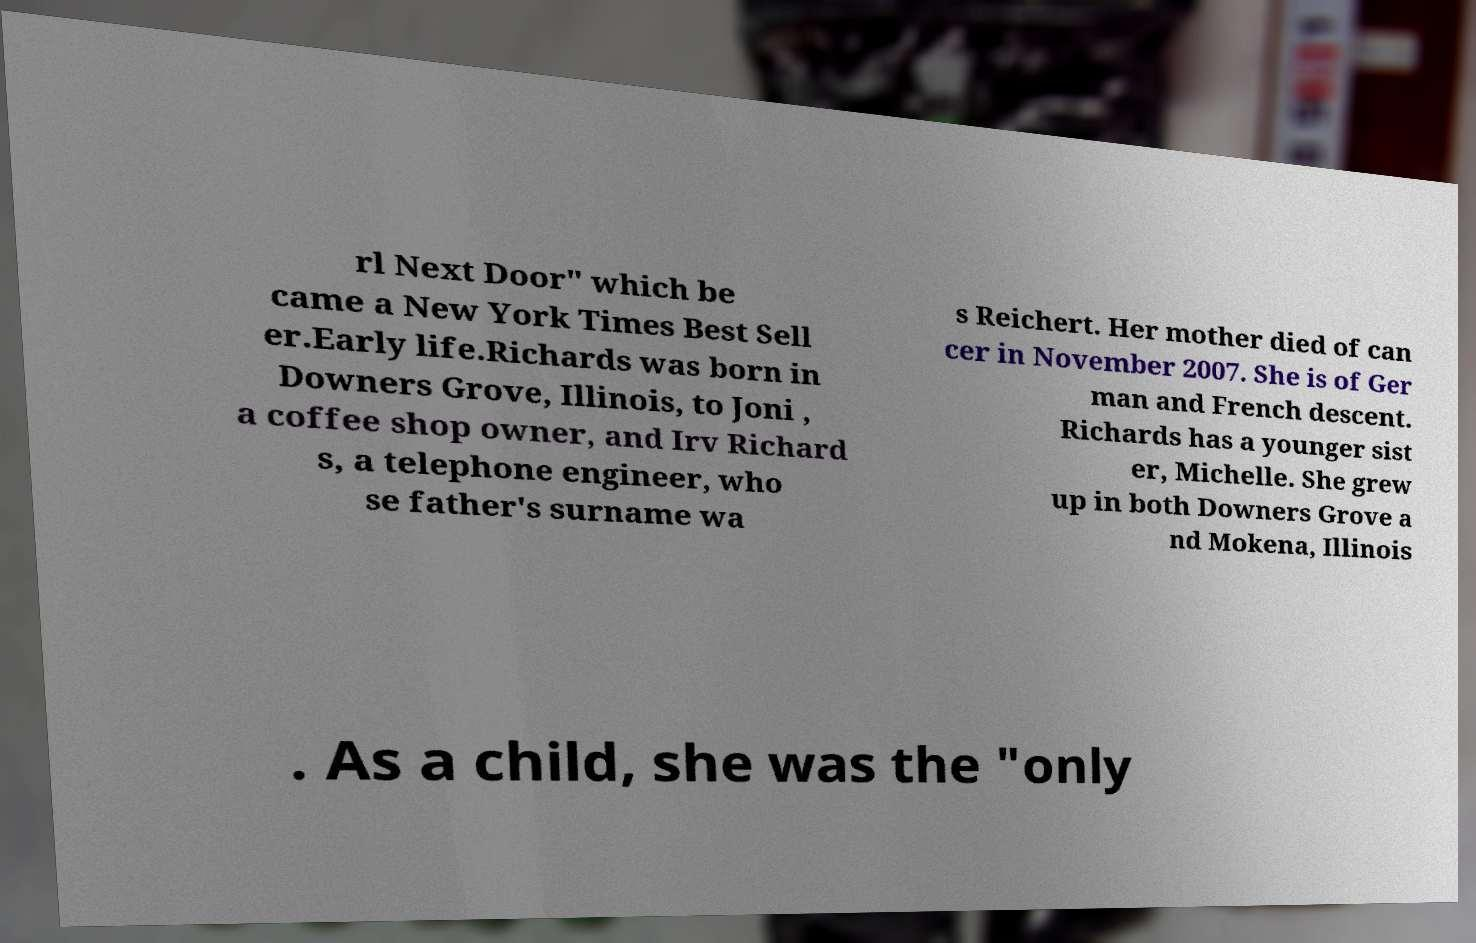Could you extract and type out the text from this image? rl Next Door" which be came a New York Times Best Sell er.Early life.Richards was born in Downers Grove, Illinois, to Joni , a coffee shop owner, and Irv Richard s, a telephone engineer, who se father's surname wa s Reichert. Her mother died of can cer in November 2007. She is of Ger man and French descent. Richards has a younger sist er, Michelle. She grew up in both Downers Grove a nd Mokena, Illinois . As a child, she was the "only 